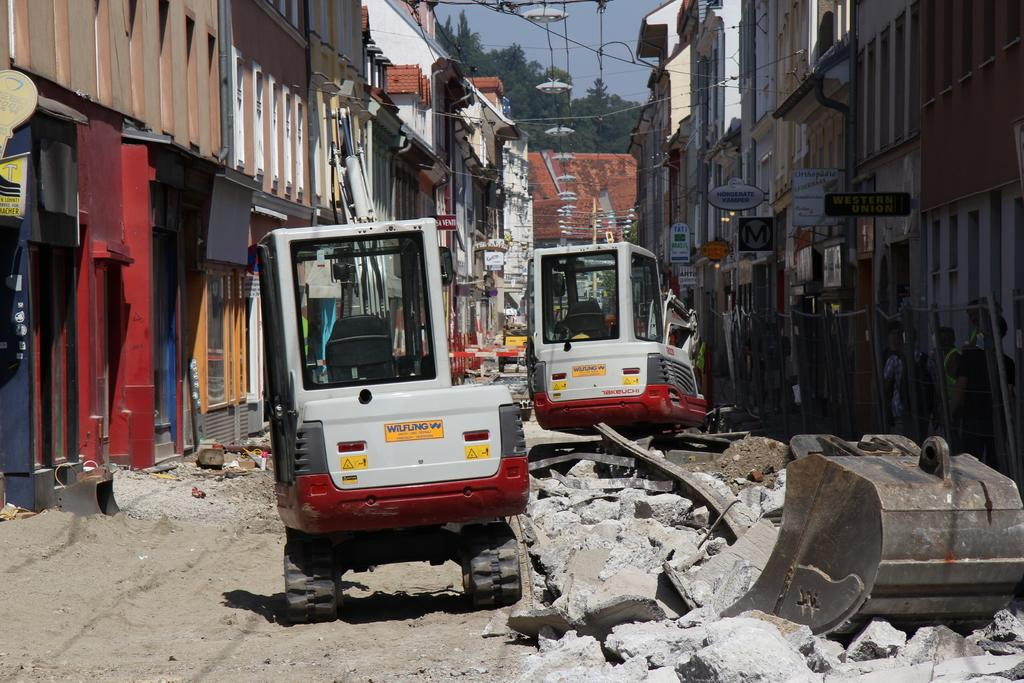What type of large machines can be seen in the image? There are cranes in the image. What structures are visible in the image? There are buildings in the image. What type of natural elements can be seen in the image? There are trees and rocks in the image. What is the condition of the sky in the image? The sky is cloudy in the image. How many cakes are being served to the achiever in the image? There are no cakes or achievers present in the image. What type of development is taking place in the image? The image does not depict any development or construction process; it only shows cranes, buildings, trees, rocks, and a cloudy sky. 